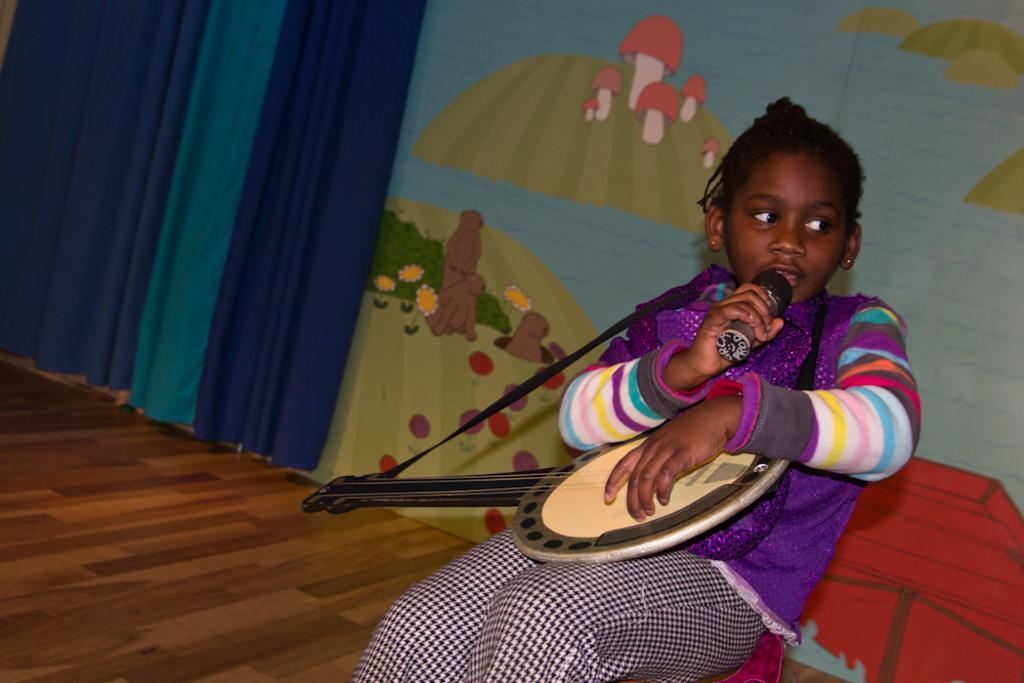How would you summarize this image in a sentence or two? There is a small girl holding a guitar and a mic in the foreground area of the image, there is a curtain and a painting on the wall in the background. 